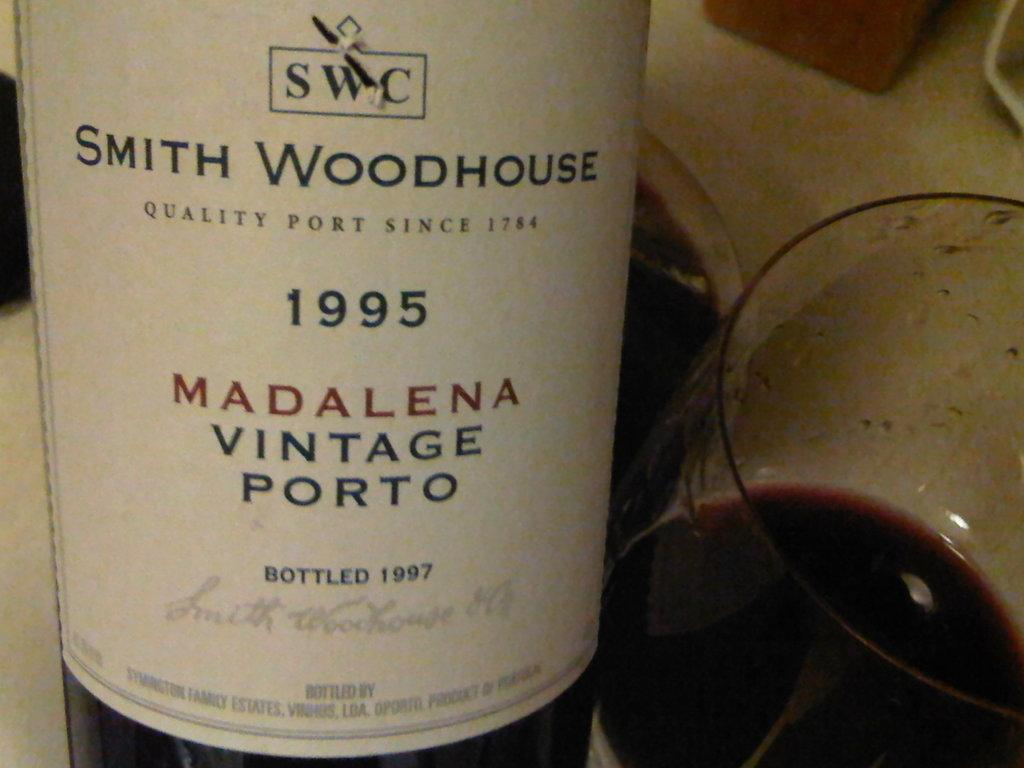What is one of the objects visible on the table in the image? There is a bottle on the table in the image. What else can be seen on the table in the image? There is a glass with a drink in the image. Can you describe any other objects on the table in the image? There are other objects on the table in the image, but their specific details are not mentioned in the provided facts. What invention is the queen using to cross the river in the image? There is no queen, invention, or river present in the image. 